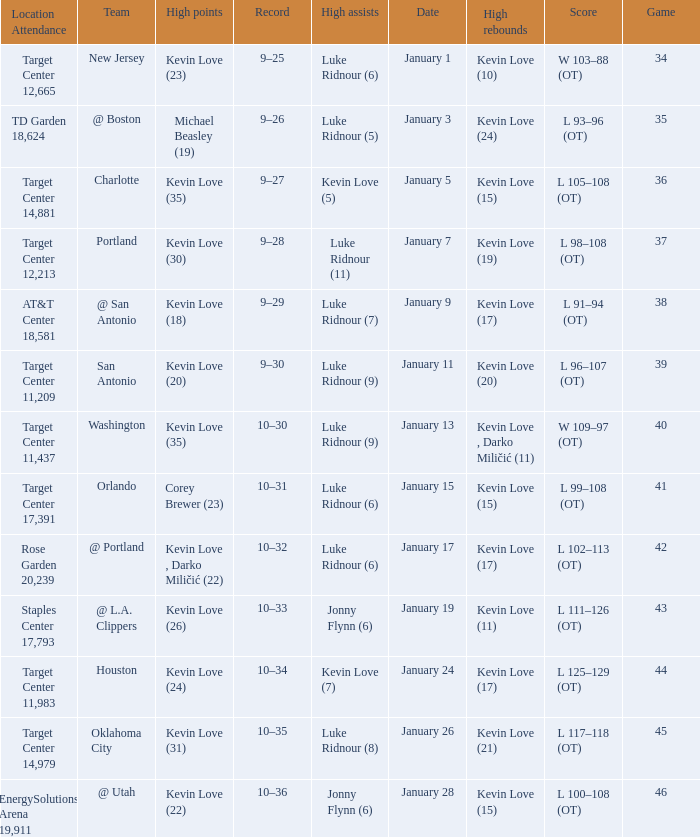What is the highest game with team @ l.a. clippers? 43.0. 